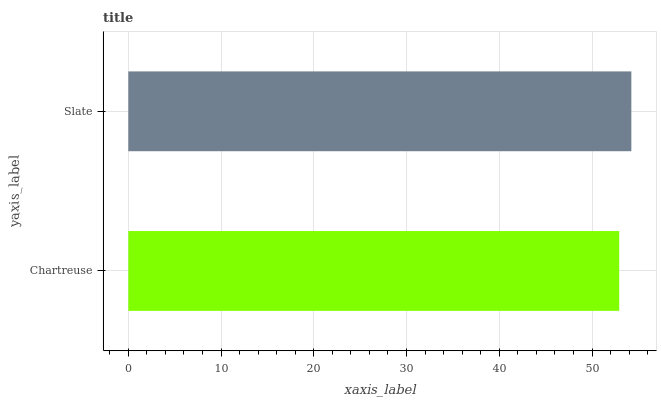Is Chartreuse the minimum?
Answer yes or no. Yes. Is Slate the maximum?
Answer yes or no. Yes. Is Slate the minimum?
Answer yes or no. No. Is Slate greater than Chartreuse?
Answer yes or no. Yes. Is Chartreuse less than Slate?
Answer yes or no. Yes. Is Chartreuse greater than Slate?
Answer yes or no. No. Is Slate less than Chartreuse?
Answer yes or no. No. Is Slate the high median?
Answer yes or no. Yes. Is Chartreuse the low median?
Answer yes or no. Yes. Is Chartreuse the high median?
Answer yes or no. No. Is Slate the low median?
Answer yes or no. No. 